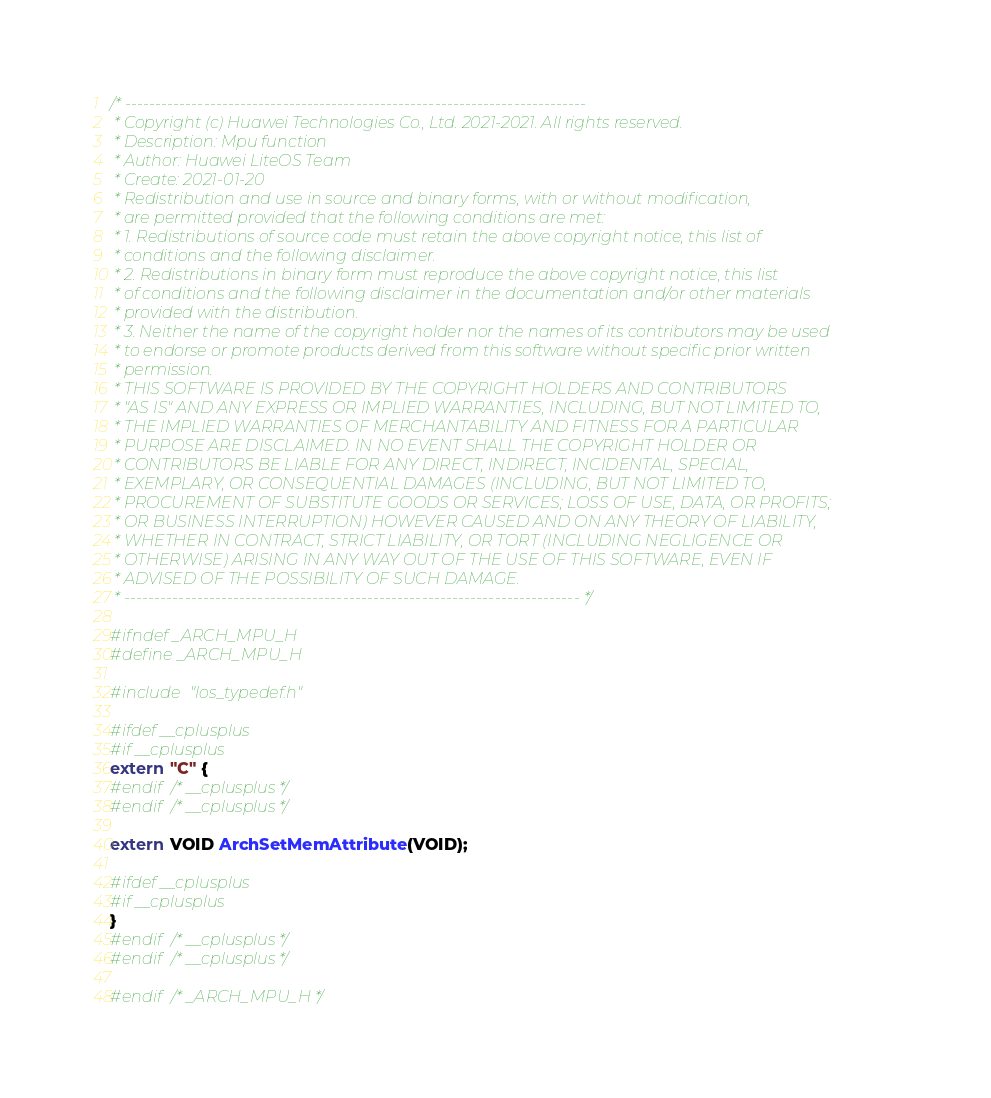<code> <loc_0><loc_0><loc_500><loc_500><_C_>/* ----------------------------------------------------------------------------
 * Copyright (c) Huawei Technologies Co., Ltd. 2021-2021. All rights reserved.
 * Description: Mpu function
 * Author: Huawei LiteOS Team
 * Create: 2021-01-20
 * Redistribution and use in source and binary forms, with or without modification,
 * are permitted provided that the following conditions are met:
 * 1. Redistributions of source code must retain the above copyright notice, this list of
 * conditions and the following disclaimer.
 * 2. Redistributions in binary form must reproduce the above copyright notice, this list
 * of conditions and the following disclaimer in the documentation and/or other materials
 * provided with the distribution.
 * 3. Neither the name of the copyright holder nor the names of its contributors may be used
 * to endorse or promote products derived from this software without specific prior written
 * permission.
 * THIS SOFTWARE IS PROVIDED BY THE COPYRIGHT HOLDERS AND CONTRIBUTORS
 * "AS IS" AND ANY EXPRESS OR IMPLIED WARRANTIES, INCLUDING, BUT NOT LIMITED TO,
 * THE IMPLIED WARRANTIES OF MERCHANTABILITY AND FITNESS FOR A PARTICULAR
 * PURPOSE ARE DISCLAIMED. IN NO EVENT SHALL THE COPYRIGHT HOLDER OR
 * CONTRIBUTORS BE LIABLE FOR ANY DIRECT, INDIRECT, INCIDENTAL, SPECIAL,
 * EXEMPLARY, OR CONSEQUENTIAL DAMAGES (INCLUDING, BUT NOT LIMITED TO,
 * PROCUREMENT OF SUBSTITUTE GOODS OR SERVICES; LOSS OF USE, DATA, OR PROFITS;
 * OR BUSINESS INTERRUPTION) HOWEVER CAUSED AND ON ANY THEORY OF LIABILITY,
 * WHETHER IN CONTRACT, STRICT LIABILITY, OR TORT (INCLUDING NEGLIGENCE OR
 * OTHERWISE) ARISING IN ANY WAY OUT OF THE USE OF THIS SOFTWARE, EVEN IF
 * ADVISED OF THE POSSIBILITY OF SUCH DAMAGE.
 * --------------------------------------------------------------------------- */

#ifndef _ARCH_MPU_H
#define _ARCH_MPU_H

#include "los_typedef.h"

#ifdef __cplusplus
#if __cplusplus
extern "C" {
#endif /* __cplusplus */
#endif /* __cplusplus */

extern VOID ArchSetMemAttribute(VOID);

#ifdef __cplusplus
#if __cplusplus
}
#endif /* __cplusplus */
#endif /* __cplusplus */

#endif /* _ARCH_MPU_H */
</code> 